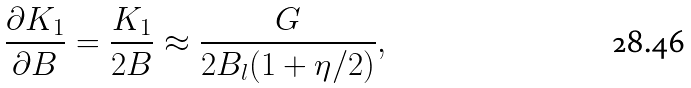Convert formula to latex. <formula><loc_0><loc_0><loc_500><loc_500>\frac { \partial K _ { 1 } } { \partial B } = \frac { K _ { 1 } } { 2 B } \approx \frac { G } { 2 B _ { l } ( 1 + \eta / 2 ) } ,</formula> 